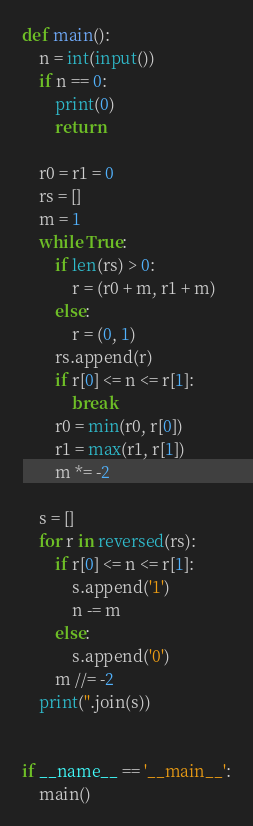Convert code to text. <code><loc_0><loc_0><loc_500><loc_500><_Python_>def main():
    n = int(input())
    if n == 0:
        print(0)
        return

    r0 = r1 = 0
    rs = []
    m = 1
    while True:
        if len(rs) > 0:
            r = (r0 + m, r1 + m)
        else:
            r = (0, 1)
        rs.append(r)
        if r[0] <= n <= r[1]:
            break
        r0 = min(r0, r[0])
        r1 = max(r1, r[1])
        m *= -2

    s = []
    for r in reversed(rs):
        if r[0] <= n <= r[1]:
            s.append('1')
            n -= m
        else:
            s.append('0')
        m //= -2
    print(''.join(s))


if __name__ == '__main__':
    main()
</code> 